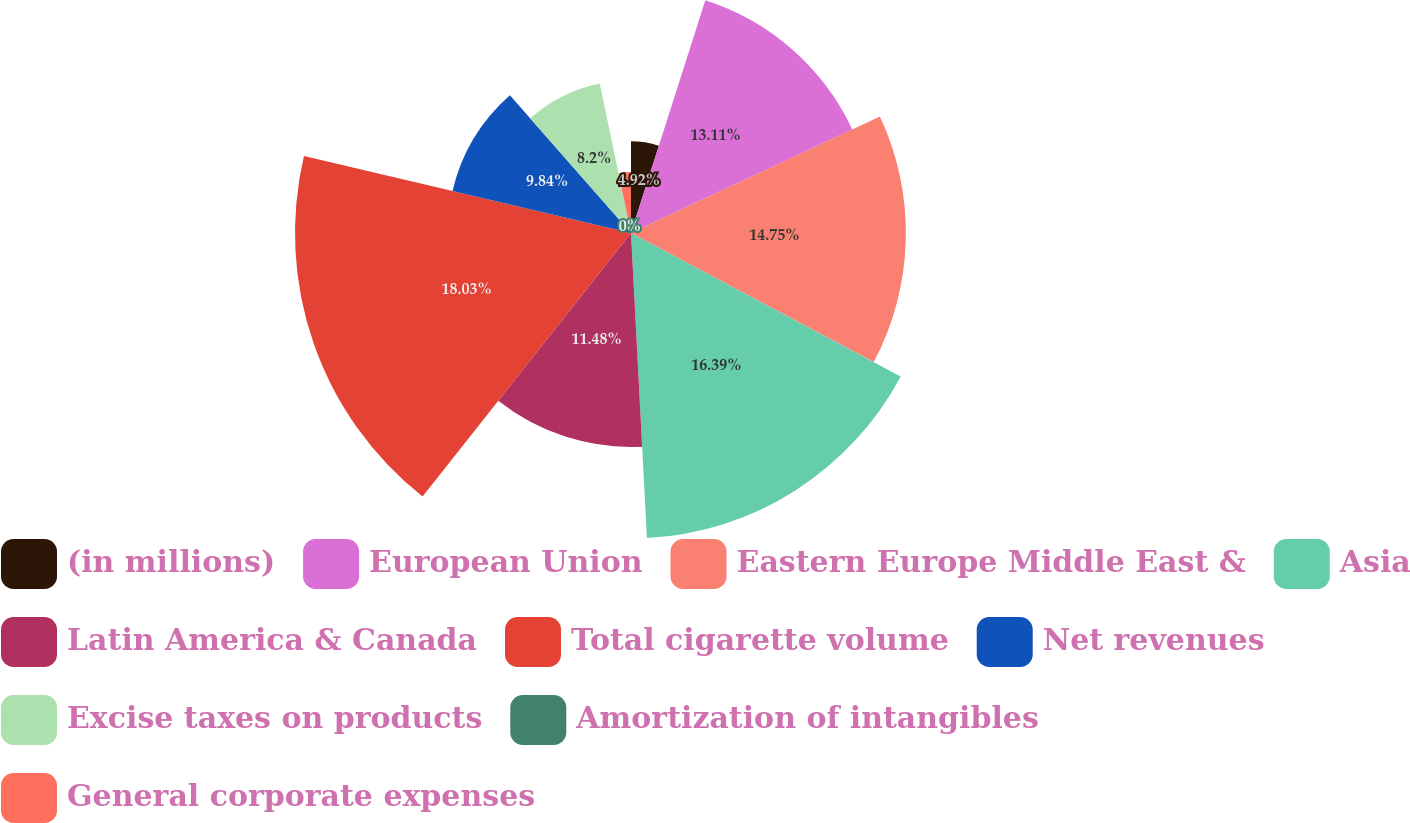<chart> <loc_0><loc_0><loc_500><loc_500><pie_chart><fcel>(in millions)<fcel>European Union<fcel>Eastern Europe Middle East &<fcel>Asia<fcel>Latin America & Canada<fcel>Total cigarette volume<fcel>Net revenues<fcel>Excise taxes on products<fcel>Amortization of intangibles<fcel>General corporate expenses<nl><fcel>4.92%<fcel>13.11%<fcel>14.75%<fcel>16.39%<fcel>11.48%<fcel>18.03%<fcel>9.84%<fcel>8.2%<fcel>0.0%<fcel>3.28%<nl></chart> 